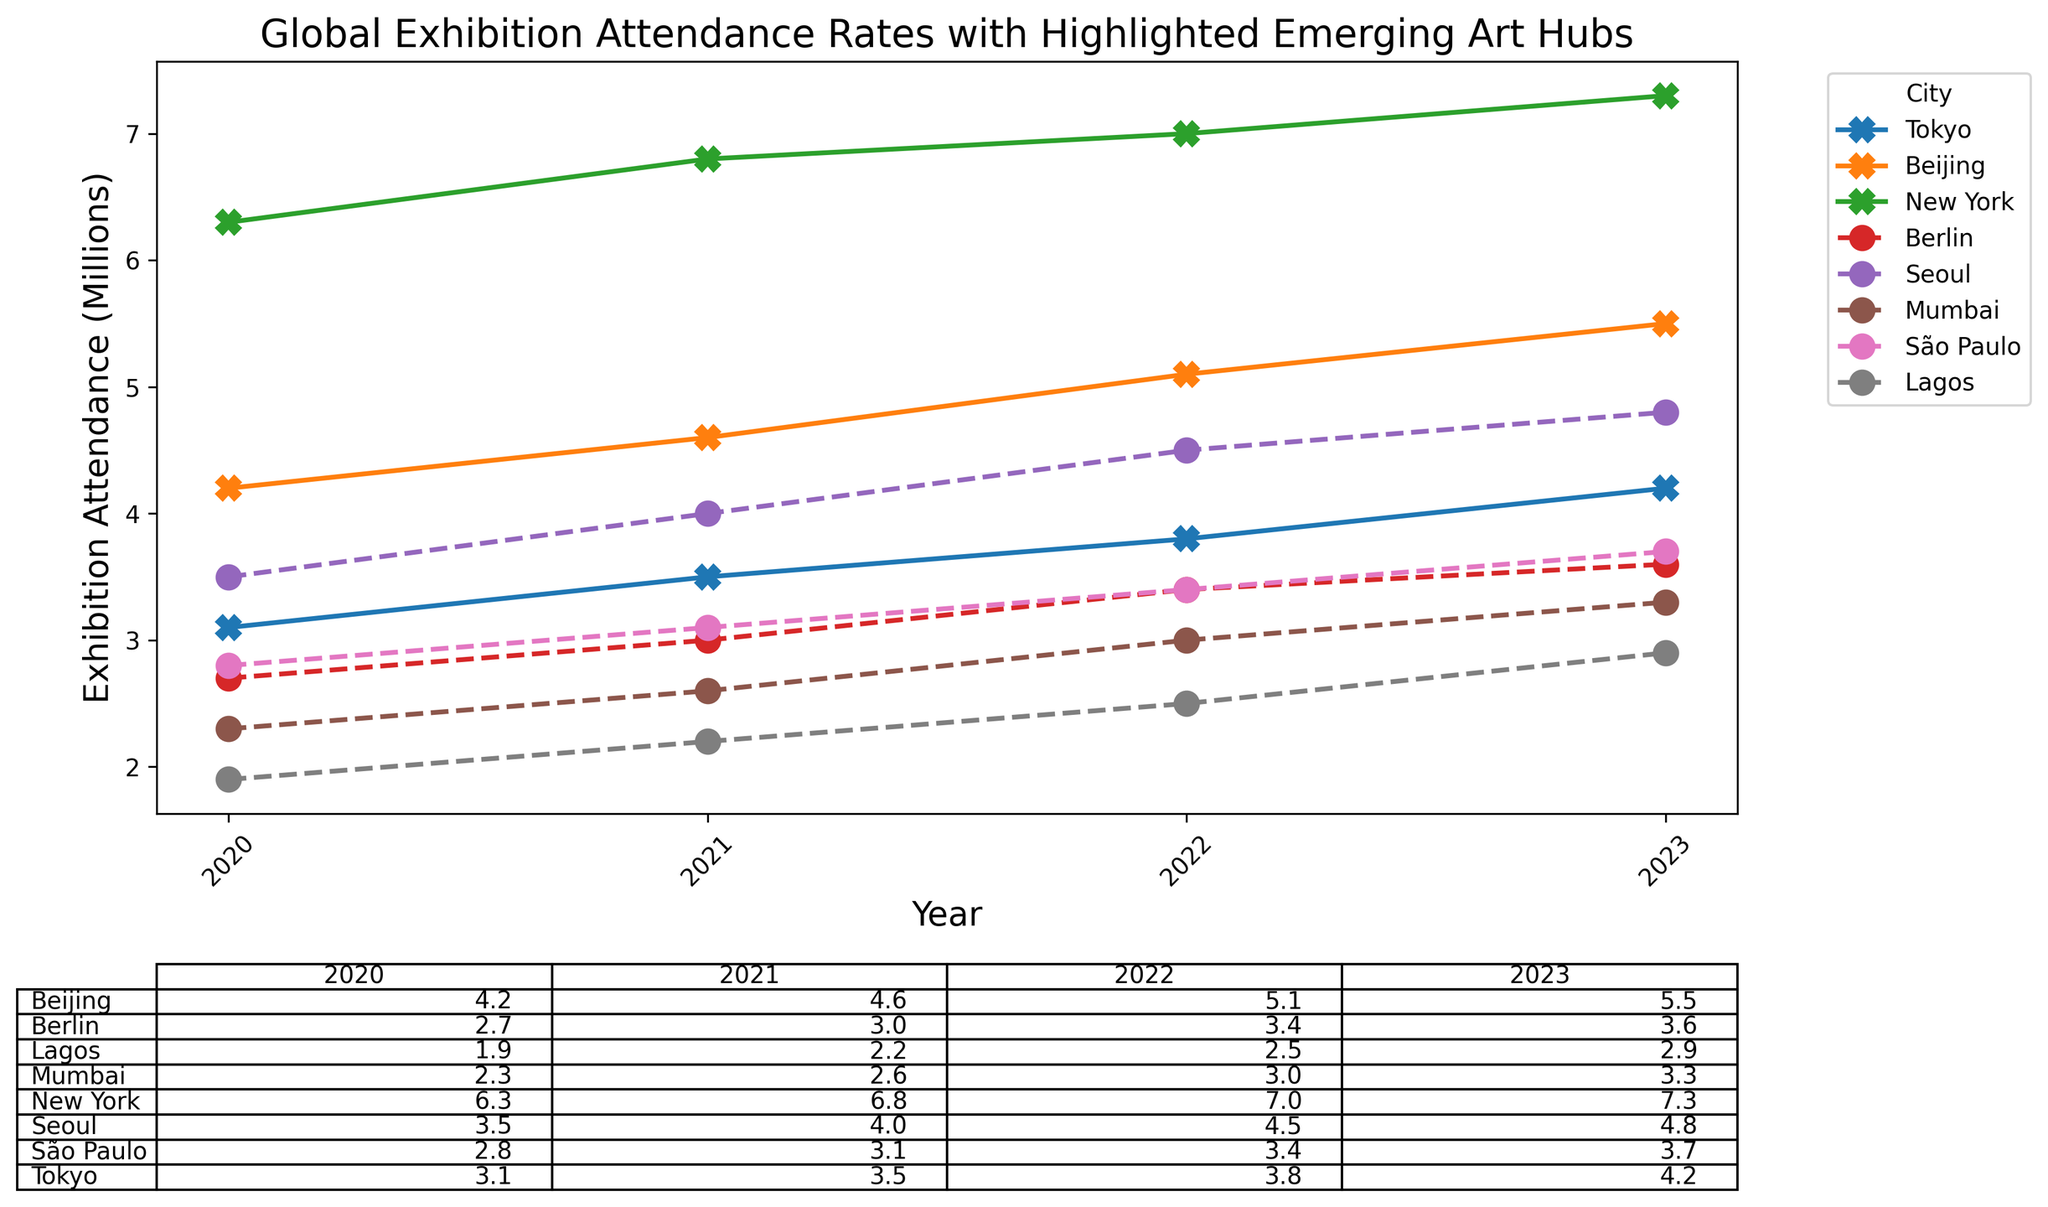Which city had the highest exhibition attendance in 2022? From the plot, you can see that New York had the highest attendance in 2022. The line for New York is the tallest in that year.
Answer: New York What is the total exhibition attendance of Berlin from 2020 to 2023? Sum Berlin's attendance data from each year as seen in the plot or table: 2.7 (2020) + 3.0 (2021) + 3.4 (2022) + 3.6 (2023) = 12.7 million.
Answer: 12.7 million Which city showed the highest increase in exhibition attendance from 2020 to 2023? The difference between 2020 and 2023 for each city is calculated, and the highest increase is seen in New York: 7.3 (2023) - 6.3 (2020) = 1.0 million.
Answer: New York Compare the exhibition attendance trend of Tokyo and Seoul from 2020 to 2023. Which one had a more consistent increase? Looking at the plot, both Tokyo and Seoul show an increasing trend, but Seoul’s trend line is smoother and more consistent without dips, while Tokyo shows more fluctuation.
Answer: Seoul Which emerging art hub in 2023 had the lowest exhibition attendance? From the plot or table, Lagos had the lowest attendance among the emerging art hubs in 2023. The marker for Lagos is at the lowest point for that year.
Answer: Lagos What was the average exhibition attendance for São Paulo from 2020 to 2023? Calculate the average: (2.8 (2020) + 3.1 (2021) + 3.4 (2022) + 3.7 (2023)) / 4 = 13 / 4 = 3.25 million.
Answer: 3.25 million How does the attendance in Mumbai evolve from 2020 to 2023? Is there any trend? The attendance for Mumbai gradually increases each year: 2.3 (2020), 2.6 (2021), 3.0 (2022), and 3.3 (2023). This suggests a consistent upward trend.
Answer: Consistent upward trend Which city had the largest single-year increase in exhibition attendance, and between which years did this occur? Beijing had the largest single-year increase in attendance between 2021 and 2022, with an increase of 4.6 (2021) to 5.1 (2022), equating to an increase of 0.5 million.
Answer: Beijing between 2021 and 2022 Compare the 2023 exhibition attendance between emerging art hubs and non-emerging art hubs. Which group had a higher average attendance? Emerging art hubs (Berlin, Seoul, Mumbai, São Paulo, Lagos) average: (3.6+4.8+3.3+3.7+2.9)/5 = 18.3/5 = 3.66 million. Non-emerging art hubs (Tokyo, Beijing, New York) average: (4.2+5.5+7.3)/3 = 17/3 = 5.67 million. Non-emerging art hubs had a higher average.
Answer: Non-emerging art hubs 